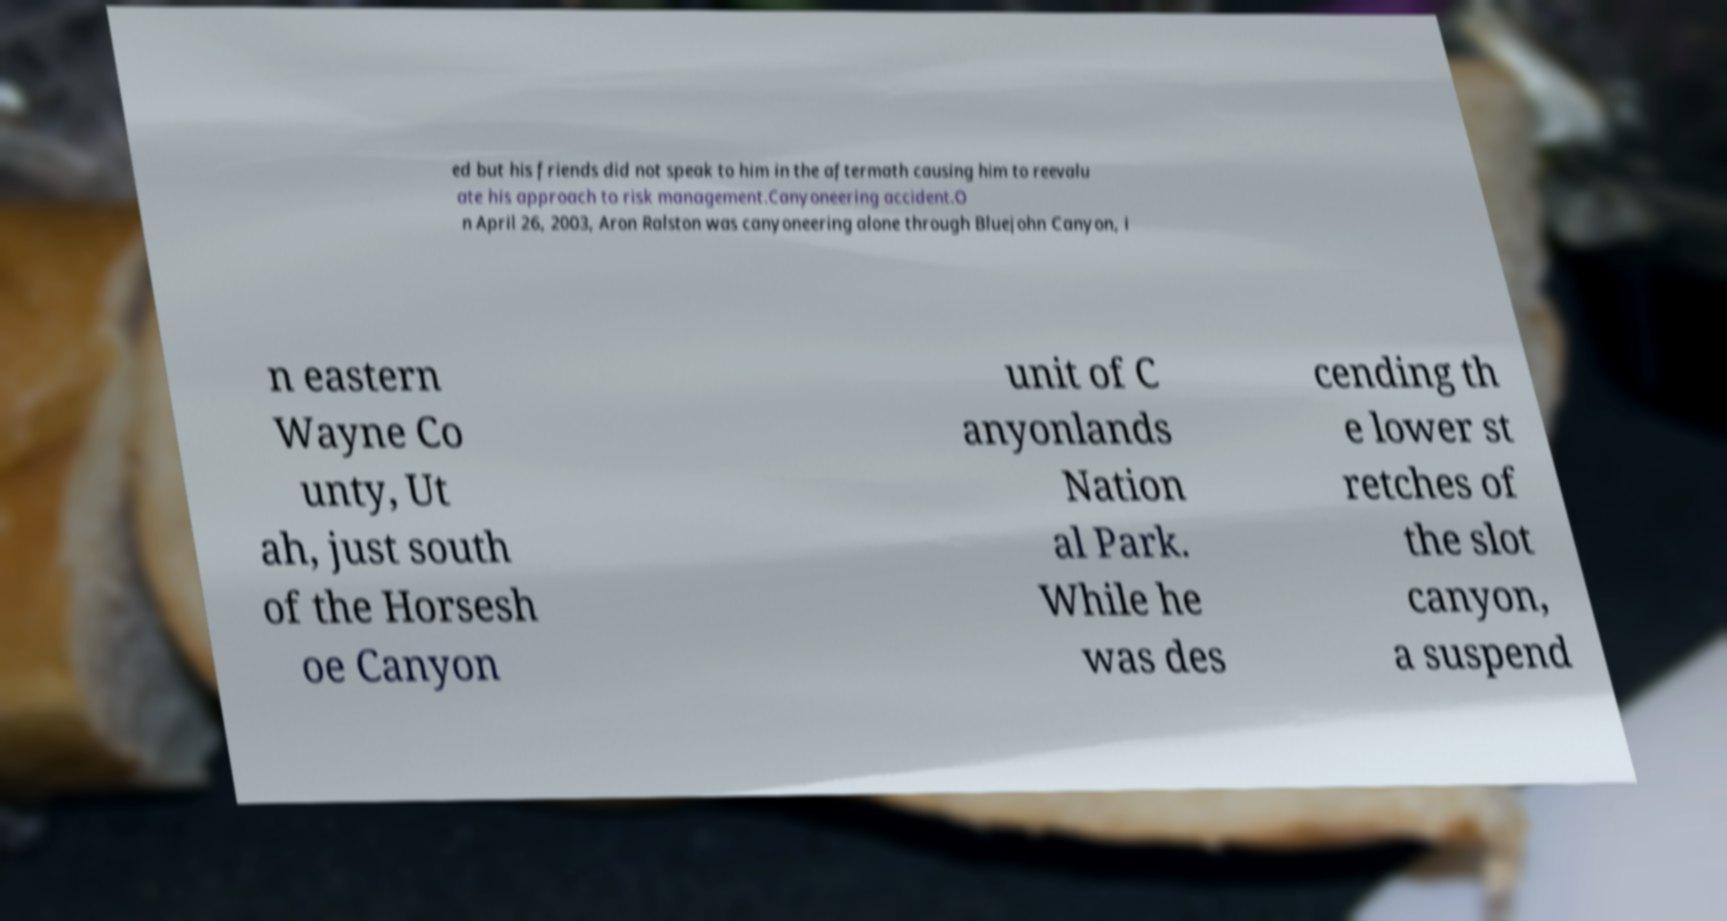For documentation purposes, I need the text within this image transcribed. Could you provide that? ed but his friends did not speak to him in the aftermath causing him to reevalu ate his approach to risk management.Canyoneering accident.O n April 26, 2003, Aron Ralston was canyoneering alone through Bluejohn Canyon, i n eastern Wayne Co unty, Ut ah, just south of the Horsesh oe Canyon unit of C anyonlands Nation al Park. While he was des cending th e lower st retches of the slot canyon, a suspend 